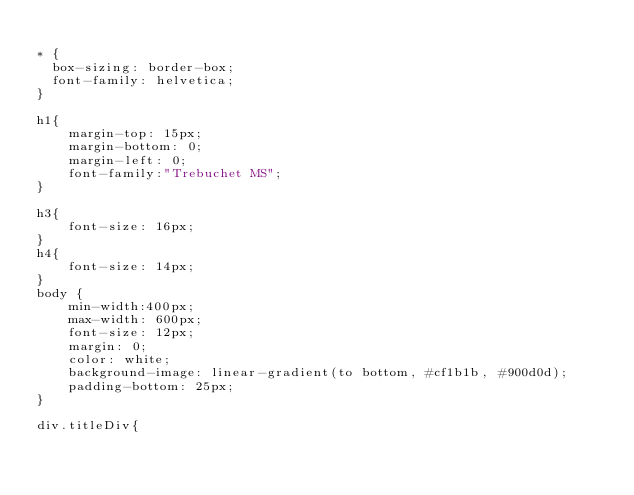<code> <loc_0><loc_0><loc_500><loc_500><_CSS_>
* {
  box-sizing: border-box;
  font-family: helvetica;
}

h1{
    margin-top: 15px;
    margin-bottom: 0;
    margin-left: 0;
    font-family:"Trebuchet MS";
}

h3{
    font-size: 16px;
}
h4{
    font-size: 14px;
}
body {
    min-width:400px;
    max-width: 600px;
    font-size: 12px;
    margin: 0;
    color: white;
    background-image: linear-gradient(to bottom, #cf1b1b, #900d0d);
    padding-bottom: 25px;
}

div.titleDiv{</code> 